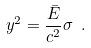<formula> <loc_0><loc_0><loc_500><loc_500>y ^ { 2 } = { \frac { \bar { E } } { c ^ { 2 } } } \sigma \ .</formula> 